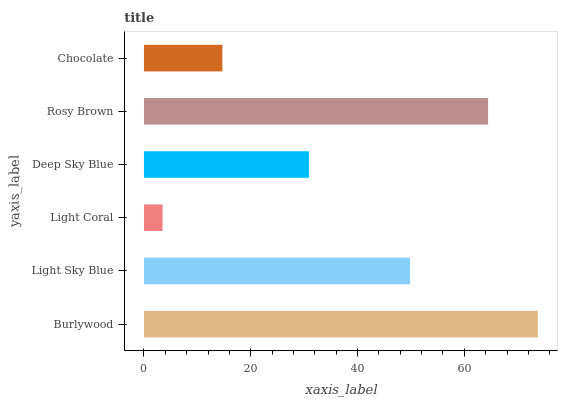Is Light Coral the minimum?
Answer yes or no. Yes. Is Burlywood the maximum?
Answer yes or no. Yes. Is Light Sky Blue the minimum?
Answer yes or no. No. Is Light Sky Blue the maximum?
Answer yes or no. No. Is Burlywood greater than Light Sky Blue?
Answer yes or no. Yes. Is Light Sky Blue less than Burlywood?
Answer yes or no. Yes. Is Light Sky Blue greater than Burlywood?
Answer yes or no. No. Is Burlywood less than Light Sky Blue?
Answer yes or no. No. Is Light Sky Blue the high median?
Answer yes or no. Yes. Is Deep Sky Blue the low median?
Answer yes or no. Yes. Is Deep Sky Blue the high median?
Answer yes or no. No. Is Light Coral the low median?
Answer yes or no. No. 